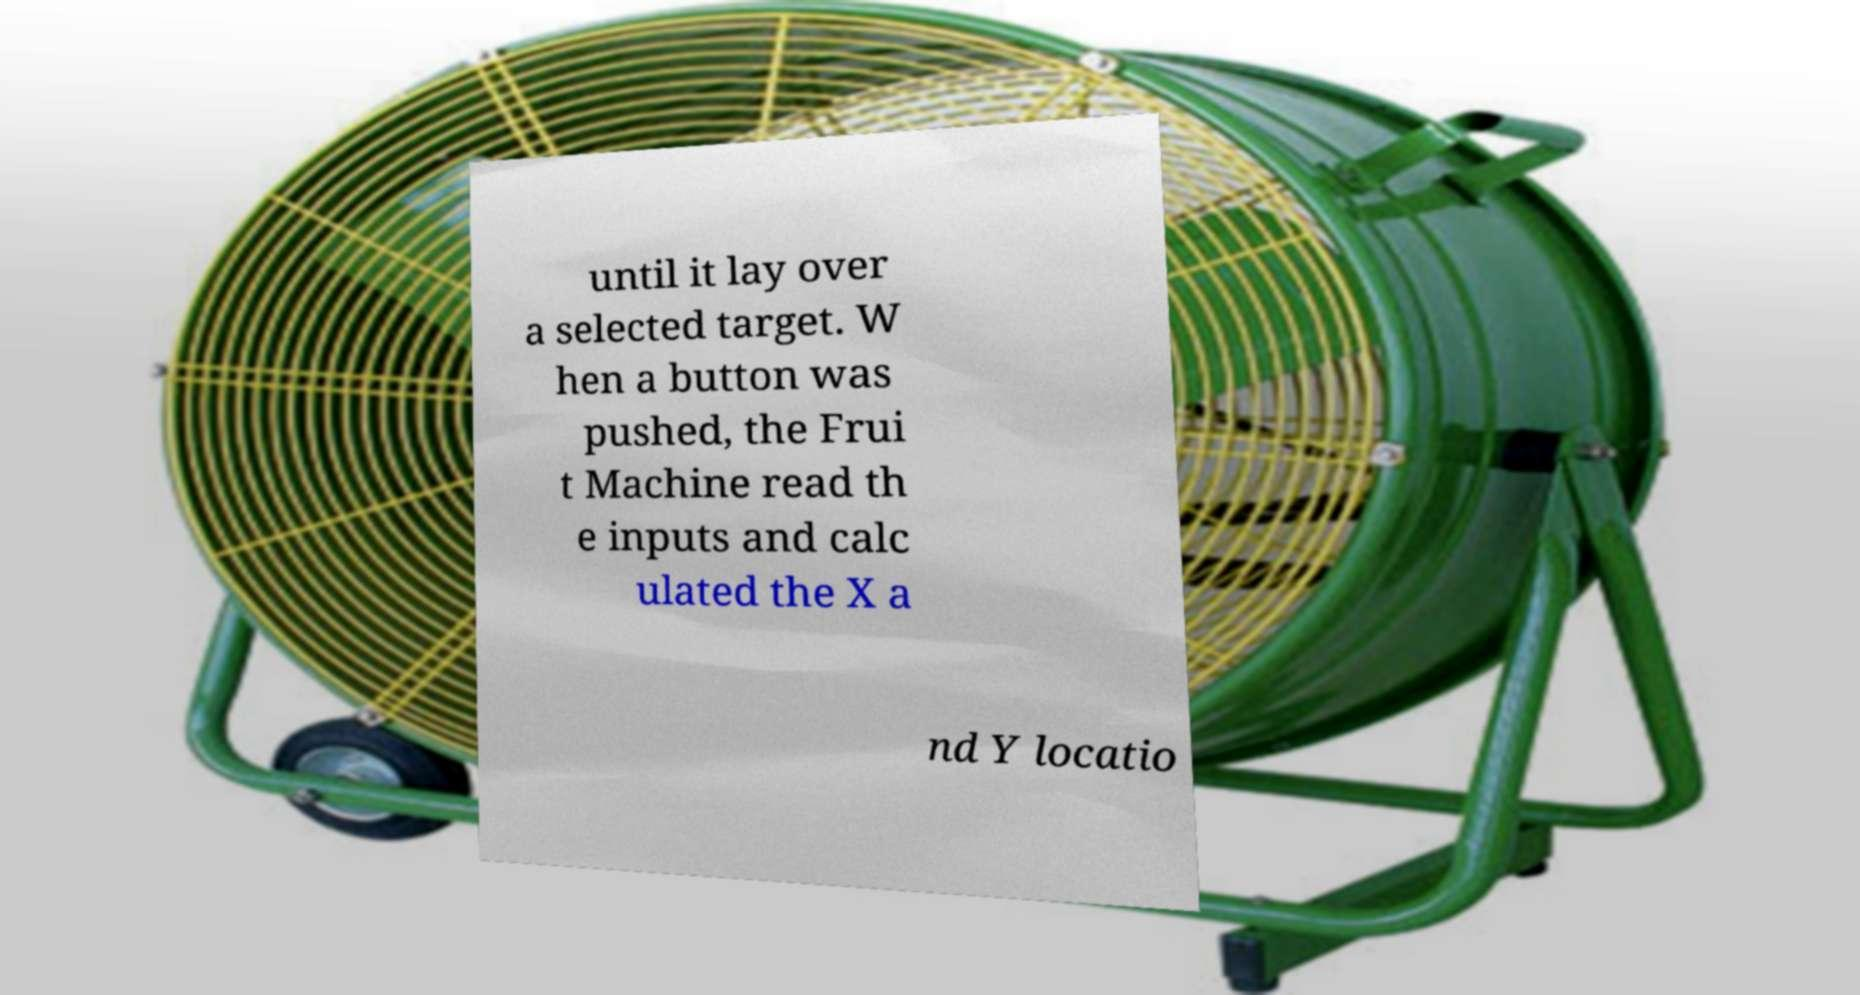Could you extract and type out the text from this image? until it lay over a selected target. W hen a button was pushed, the Frui t Machine read th e inputs and calc ulated the X a nd Y locatio 